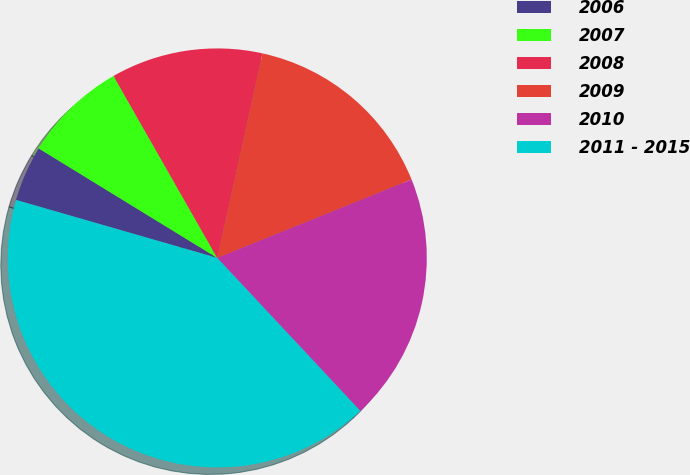<chart> <loc_0><loc_0><loc_500><loc_500><pie_chart><fcel>2006<fcel>2007<fcel>2008<fcel>2009<fcel>2010<fcel>2011 - 2015<nl><fcel>4.29%<fcel>8.0%<fcel>11.71%<fcel>15.43%<fcel>19.14%<fcel>41.43%<nl></chart> 